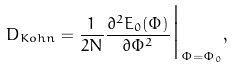Convert formula to latex. <formula><loc_0><loc_0><loc_500><loc_500>D _ { K o h n } = \frac { 1 } { 2 N } \frac { \partial ^ { 2 } E _ { 0 } ( \Phi ) } { \partial \Phi ^ { 2 } } \Big | _ { \Phi = \Phi _ { 0 } } ,</formula> 